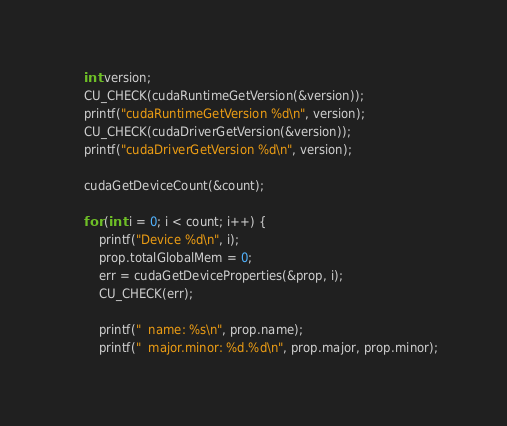<code> <loc_0><loc_0><loc_500><loc_500><_Cuda_>
	int version;
	CU_CHECK(cudaRuntimeGetVersion(&version));
	printf("cudaRuntimeGetVersion %d\n", version);
	CU_CHECK(cudaDriverGetVersion(&version));
	printf("cudaDriverGetVersion %d\n", version);

	cudaGetDeviceCount(&count);

	for (int i = 0; i < count; i++) {
		printf("Device %d\n", i);
		prop.totalGlobalMem = 0;
		err = cudaGetDeviceProperties(&prop, i);
		CU_CHECK(err);

		printf("  name: %s\n", prop.name);
		printf("  major.minor: %d.%d\n", prop.major, prop.minor);</code> 